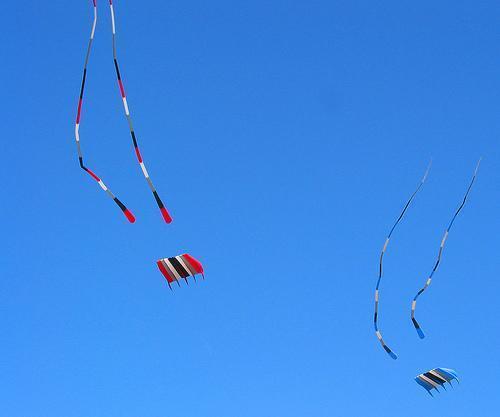How many kites are there?
Give a very brief answer. 2. 